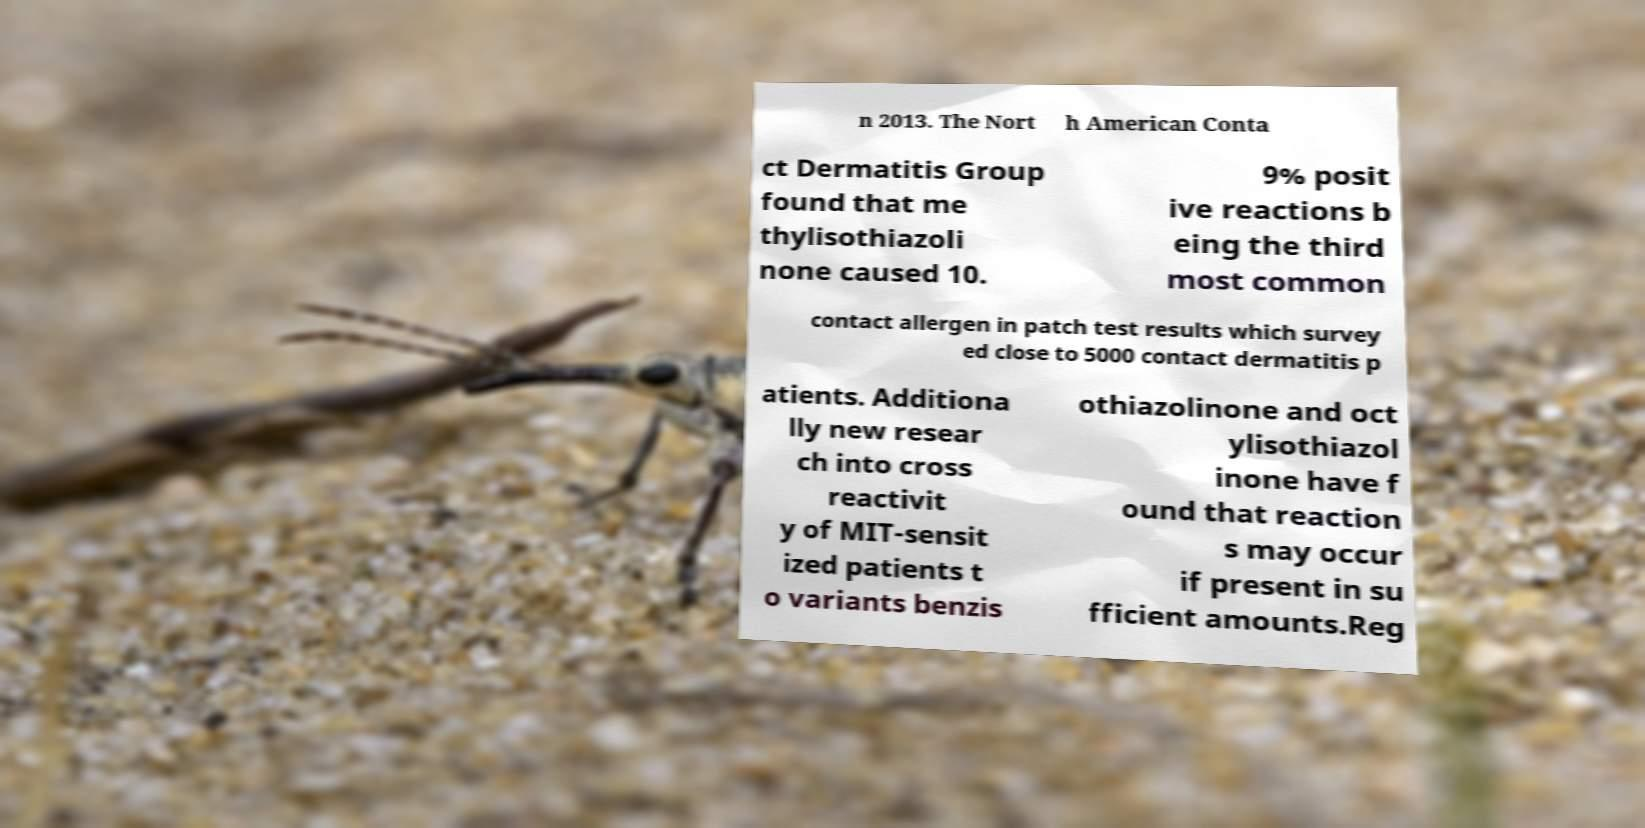I need the written content from this picture converted into text. Can you do that? n 2013. The Nort h American Conta ct Dermatitis Group found that me thylisothiazoli none caused 10. 9% posit ive reactions b eing the third most common contact allergen in patch test results which survey ed close to 5000 contact dermatitis p atients. Additiona lly new resear ch into cross reactivit y of MIT-sensit ized patients t o variants benzis othiazolinone and oct ylisothiazol inone have f ound that reaction s may occur if present in su fficient amounts.Reg 